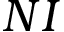Convert formula to latex. <formula><loc_0><loc_0><loc_500><loc_500>N I</formula> 